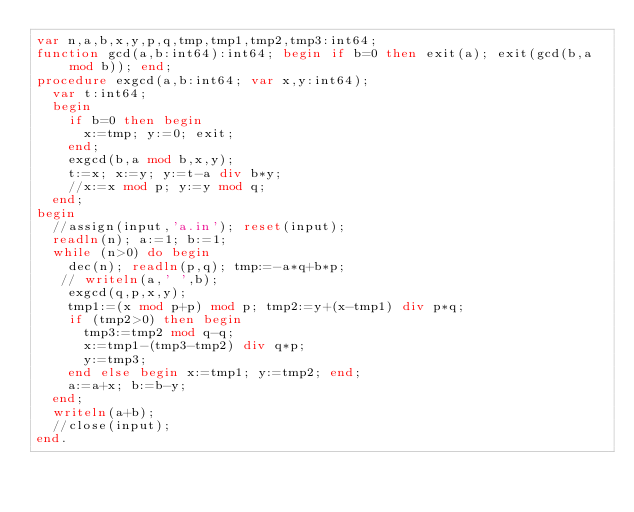<code> <loc_0><loc_0><loc_500><loc_500><_Pascal_>var n,a,b,x,y,p,q,tmp,tmp1,tmp2,tmp3:int64;
function gcd(a,b:int64):int64; begin if b=0 then exit(a); exit(gcd(b,a mod b)); end;
procedure exgcd(a,b:int64; var x,y:int64);
  var t:int64;
  begin
    if b=0 then begin
      x:=tmp; y:=0; exit;
    end;
    exgcd(b,a mod b,x,y);
    t:=x; x:=y; y:=t-a div b*y;
    //x:=x mod p; y:=y mod q;
  end;
begin
  //assign(input,'a.in'); reset(input);
  readln(n); a:=1; b:=1;
  while (n>0) do begin
    dec(n); readln(p,q); tmp:=-a*q+b*p;
   // writeln(a,' ',b);
    exgcd(q,p,x,y);
    tmp1:=(x mod p+p) mod p; tmp2:=y+(x-tmp1) div p*q;
    if (tmp2>0) then begin
      tmp3:=tmp2 mod q-q;
      x:=tmp1-(tmp3-tmp2) div q*p;
      y:=tmp3;
    end else begin x:=tmp1; y:=tmp2; end;
    a:=a+x; b:=b-y;
  end;
  writeln(a+b);
  //close(input);
end.
</code> 